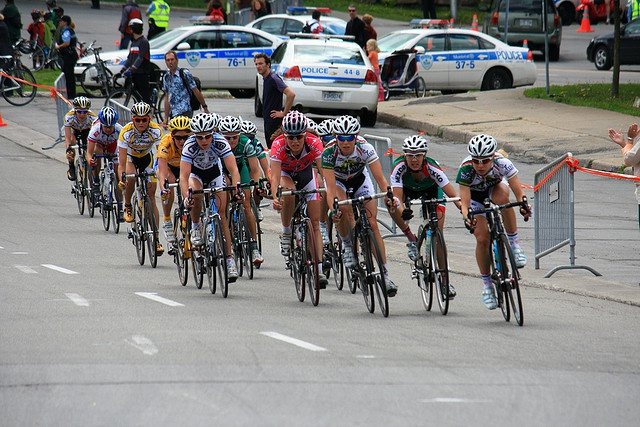Describe the objects in this image and their specific colors. I can see car in black, lightgray, darkgray, and gray tones, car in black, darkgray, lightgray, and gray tones, car in black, darkgray, lightgray, and gray tones, people in black, maroon, gray, and brown tones, and people in black, brown, gray, and maroon tones in this image. 